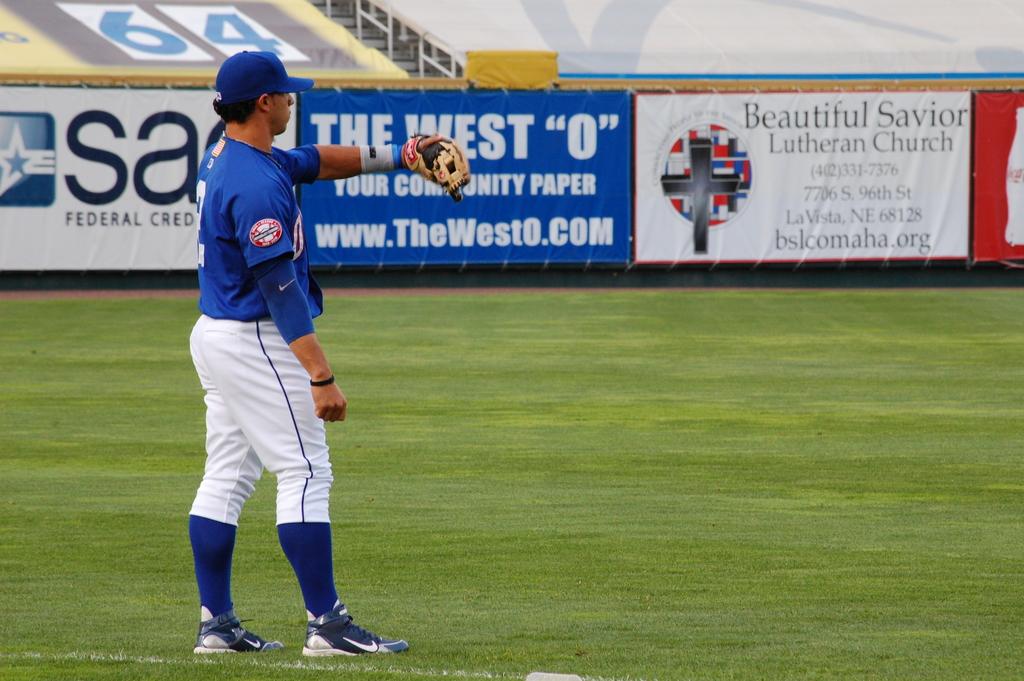What is the name of the church on the advertising banner?
Your answer should be compact. Beautiful savior lutheran church. What is the website for the westo?
Provide a short and direct response. Www.thewesto.com. 